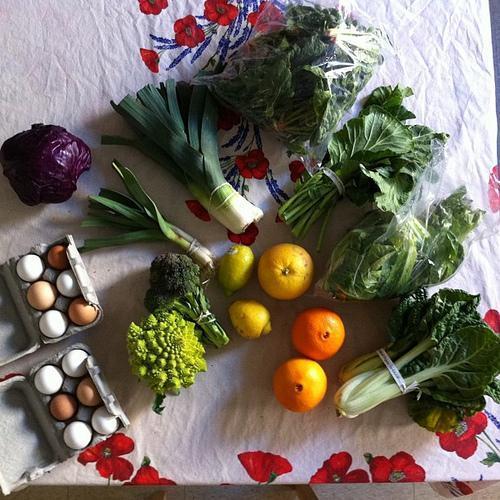How many white eggs are in the cartons?
Give a very brief answer. 7. 